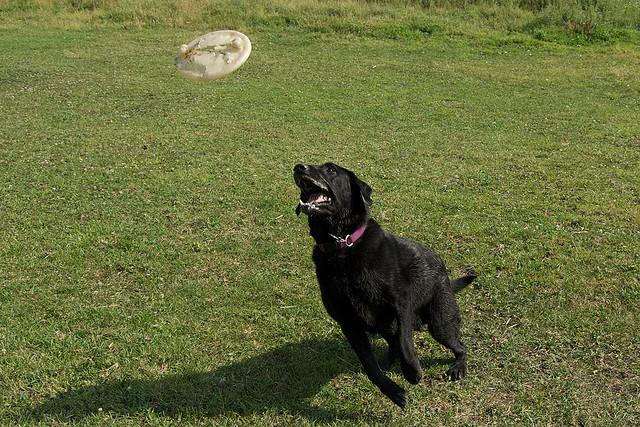How many animals are pictured?
Give a very brief answer. 1. Is this dog a male?
Quick response, please. Yes. What color is the frisbee?
Write a very short answer. White. What is the object that the dog is trying to catch?
Give a very brief answer. Frisbee. What is the color of the dog's collar?
Answer briefly. Red. How many dogs do you see?
Keep it brief. 1. Is there a human in the image?
Keep it brief. No. What is the dog catching?
Write a very short answer. Frisbee. Is this dog straining to catch the frisbee?
Answer briefly. Yes. Who is playing with dog?
Keep it brief. Owner. Does the dog have four legs?
Keep it brief. Yes. 